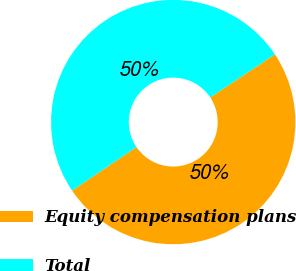Convert chart. <chart><loc_0><loc_0><loc_500><loc_500><pie_chart><fcel>Equity compensation plans<fcel>Total<nl><fcel>49.88%<fcel>50.12%<nl></chart> 